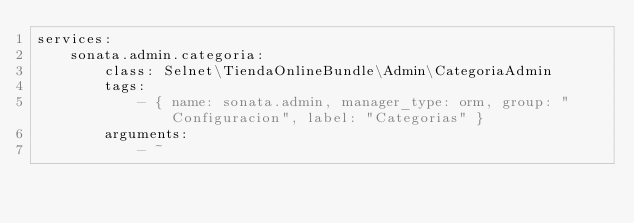Convert code to text. <code><loc_0><loc_0><loc_500><loc_500><_YAML_>services:
    sonata.admin.categoria:
        class: Selnet\TiendaOnlineBundle\Admin\CategoriaAdmin
        tags:
            - { name: sonata.admin, manager_type: orm, group: "Configuracion", label: "Categorias" }
        arguments:
            - ~</code> 